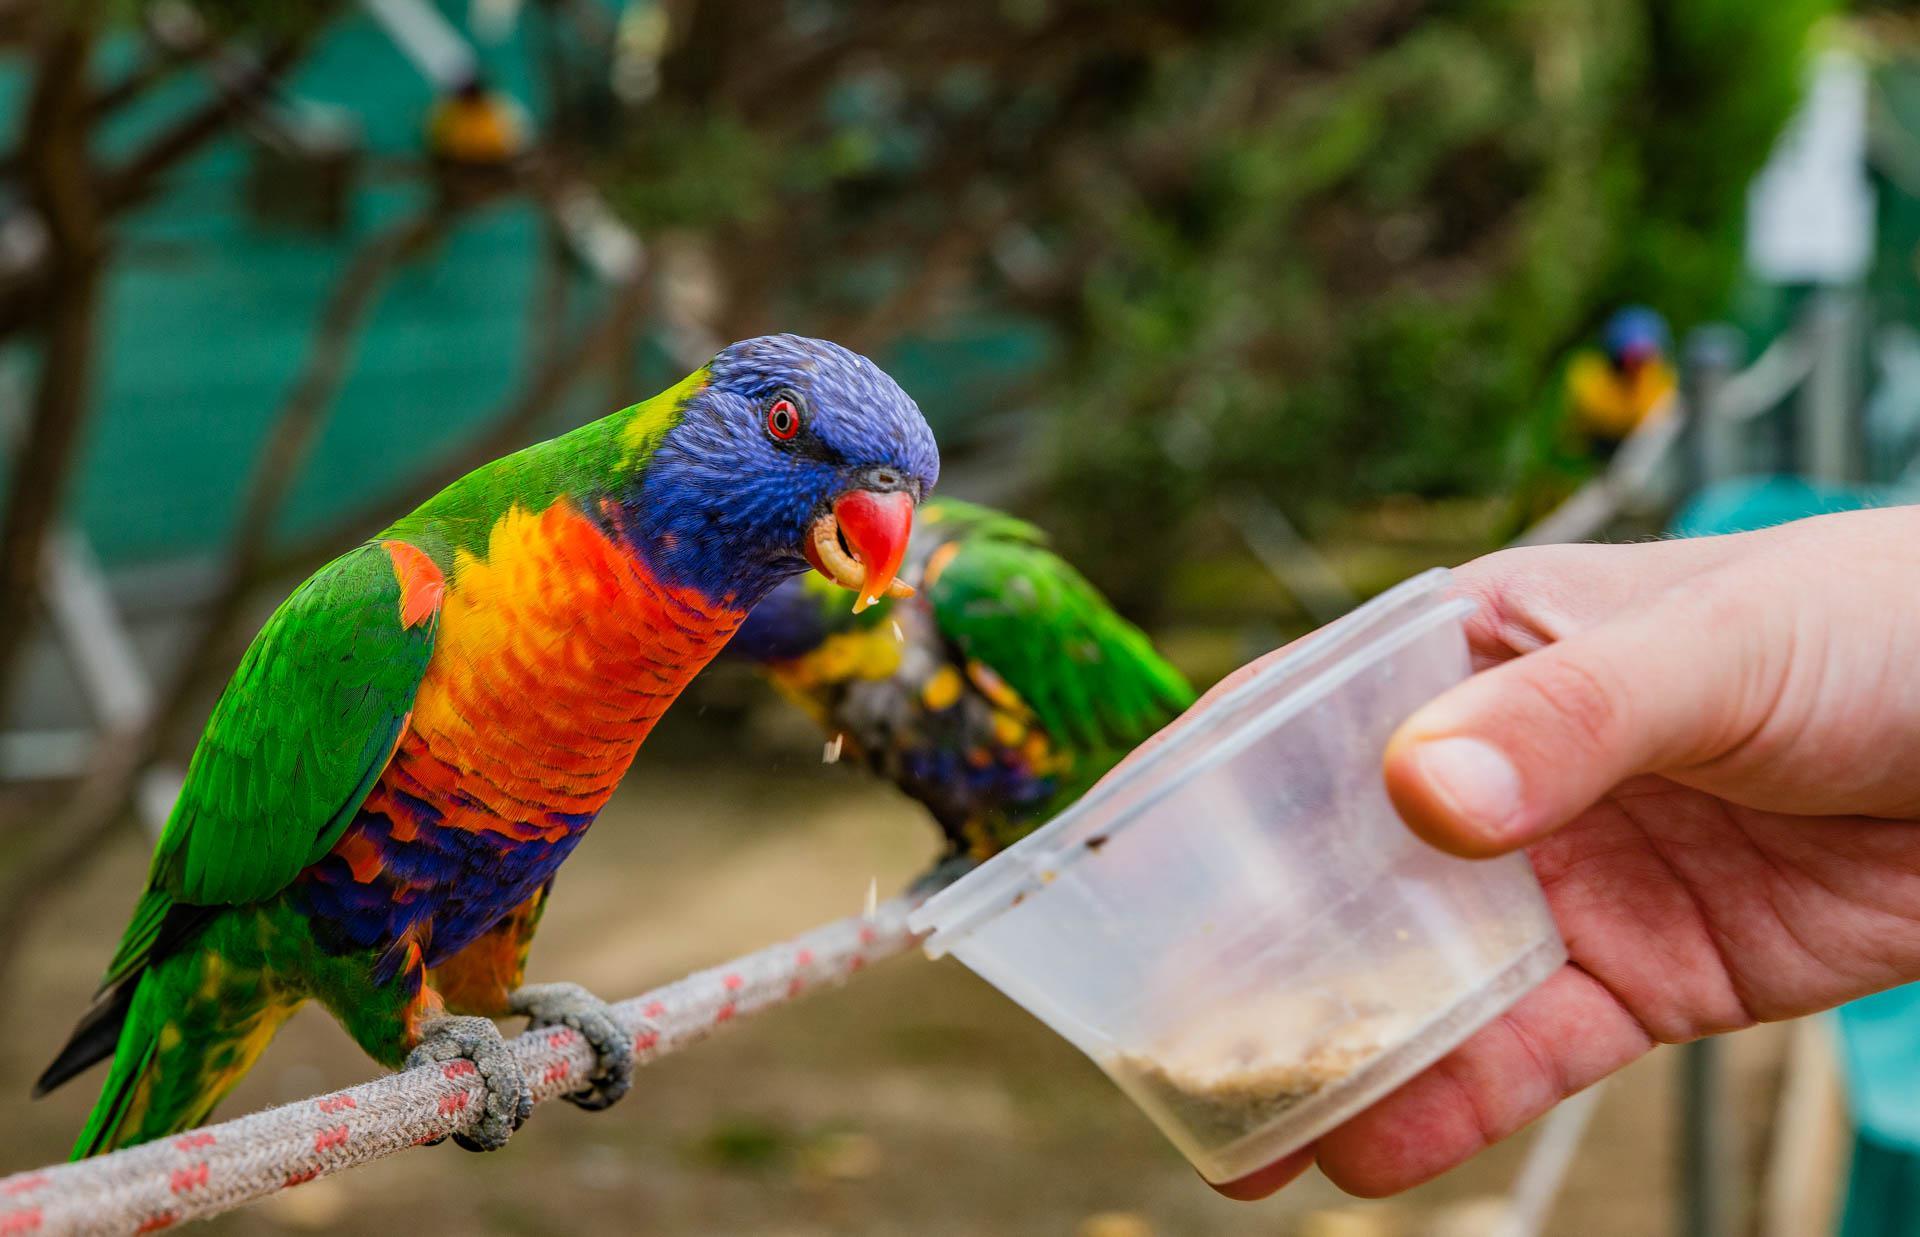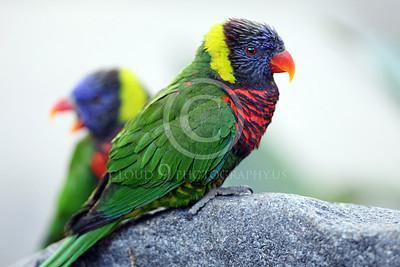The first image is the image on the left, the second image is the image on the right. Assess this claim about the two images: "A person's hand is visible offering a clear plastic cup to one or more colorful birds to feed fro". Correct or not? Answer yes or no. Yes. The first image is the image on the left, the second image is the image on the right. Analyze the images presented: Is the assertion "In one image, a hand is holding a plastic cup out for a parrot." valid? Answer yes or no. Yes. 